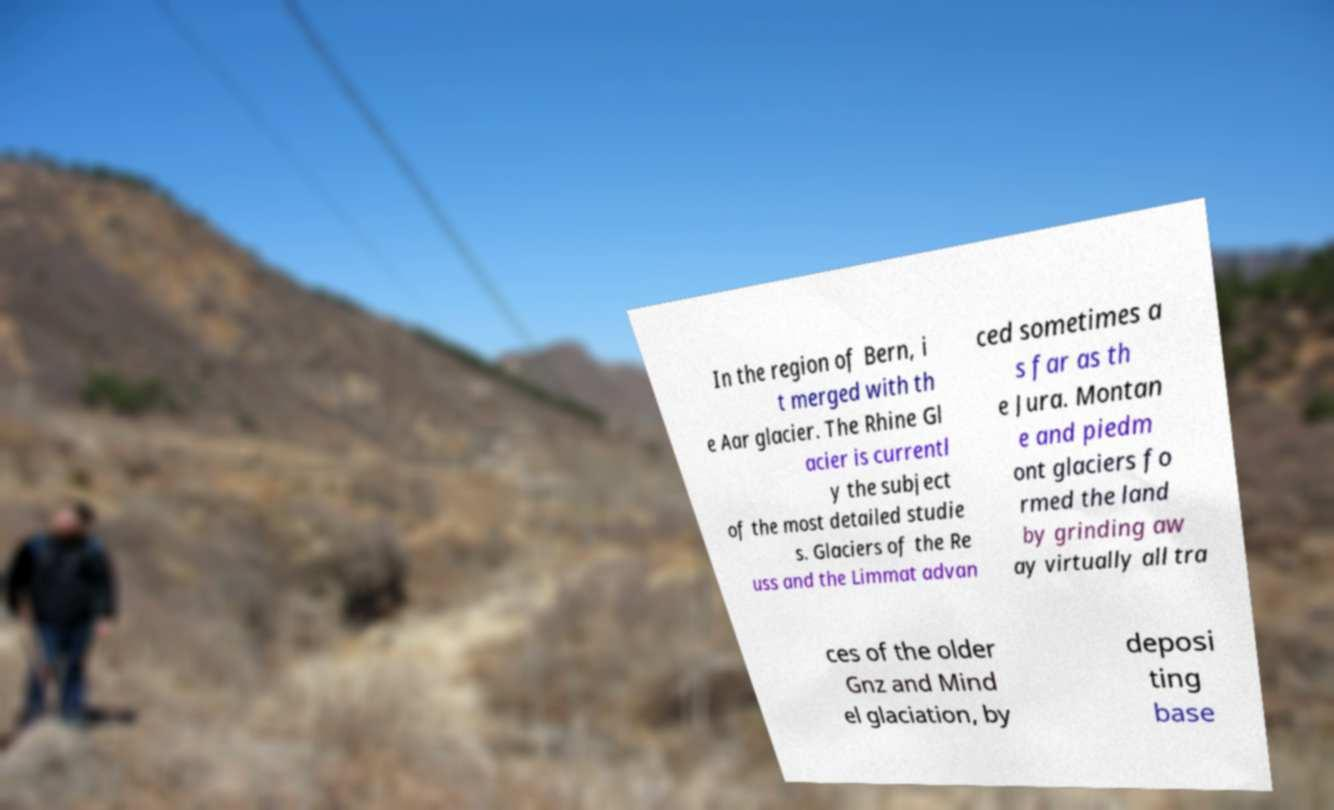For documentation purposes, I need the text within this image transcribed. Could you provide that? In the region of Bern, i t merged with th e Aar glacier. The Rhine Gl acier is currentl y the subject of the most detailed studie s. Glaciers of the Re uss and the Limmat advan ced sometimes a s far as th e Jura. Montan e and piedm ont glaciers fo rmed the land by grinding aw ay virtually all tra ces of the older Gnz and Mind el glaciation, by deposi ting base 